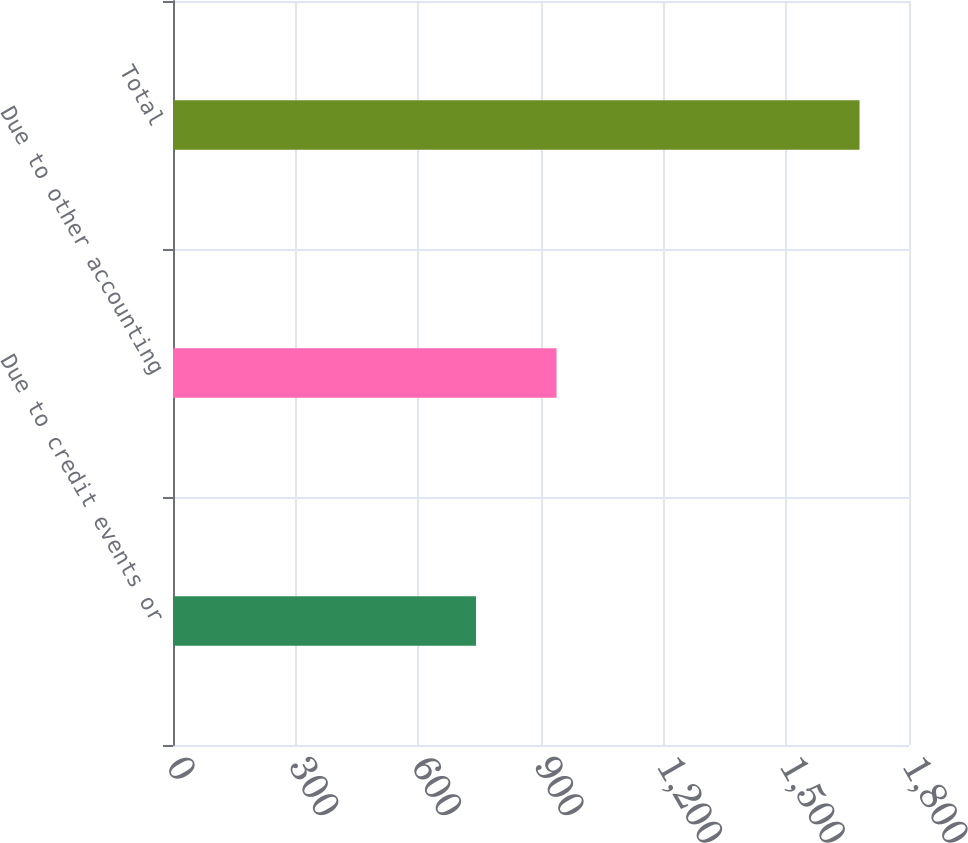Convert chart to OTSL. <chart><loc_0><loc_0><loc_500><loc_500><bar_chart><fcel>Due to credit events or<fcel>Due to other accounting<fcel>Total<nl><fcel>741<fcel>938<fcel>1679<nl></chart> 